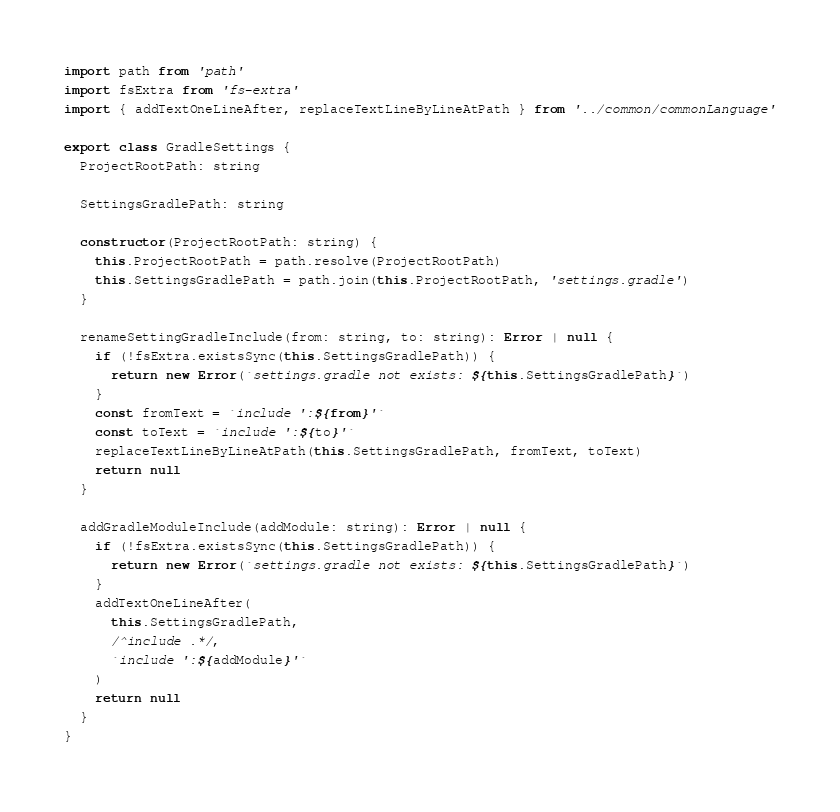Convert code to text. <code><loc_0><loc_0><loc_500><loc_500><_TypeScript_>import path from 'path'
import fsExtra from 'fs-extra'
import { addTextOneLineAfter, replaceTextLineByLineAtPath } from '../common/commonLanguage'

export class GradleSettings {
  ProjectRootPath: string

  SettingsGradlePath: string

  constructor(ProjectRootPath: string) {
    this.ProjectRootPath = path.resolve(ProjectRootPath)
    this.SettingsGradlePath = path.join(this.ProjectRootPath, 'settings.gradle')
  }

  renameSettingGradleInclude(from: string, to: string): Error | null {
    if (!fsExtra.existsSync(this.SettingsGradlePath)) {
      return new Error(`settings.gradle not exists: ${this.SettingsGradlePath}`)
    }
    const fromText = `include ':${from}'`
    const toText = `include ':${to}'`
    replaceTextLineByLineAtPath(this.SettingsGradlePath, fromText, toText)
    return null
  }

  addGradleModuleInclude(addModule: string): Error | null {
    if (!fsExtra.existsSync(this.SettingsGradlePath)) {
      return new Error(`settings.gradle not exists: ${this.SettingsGradlePath}`)
    }
    addTextOneLineAfter(
      this.SettingsGradlePath,
      /^include .*/,
      `include ':${addModule}'`
    )
    return null
  }
}</code> 